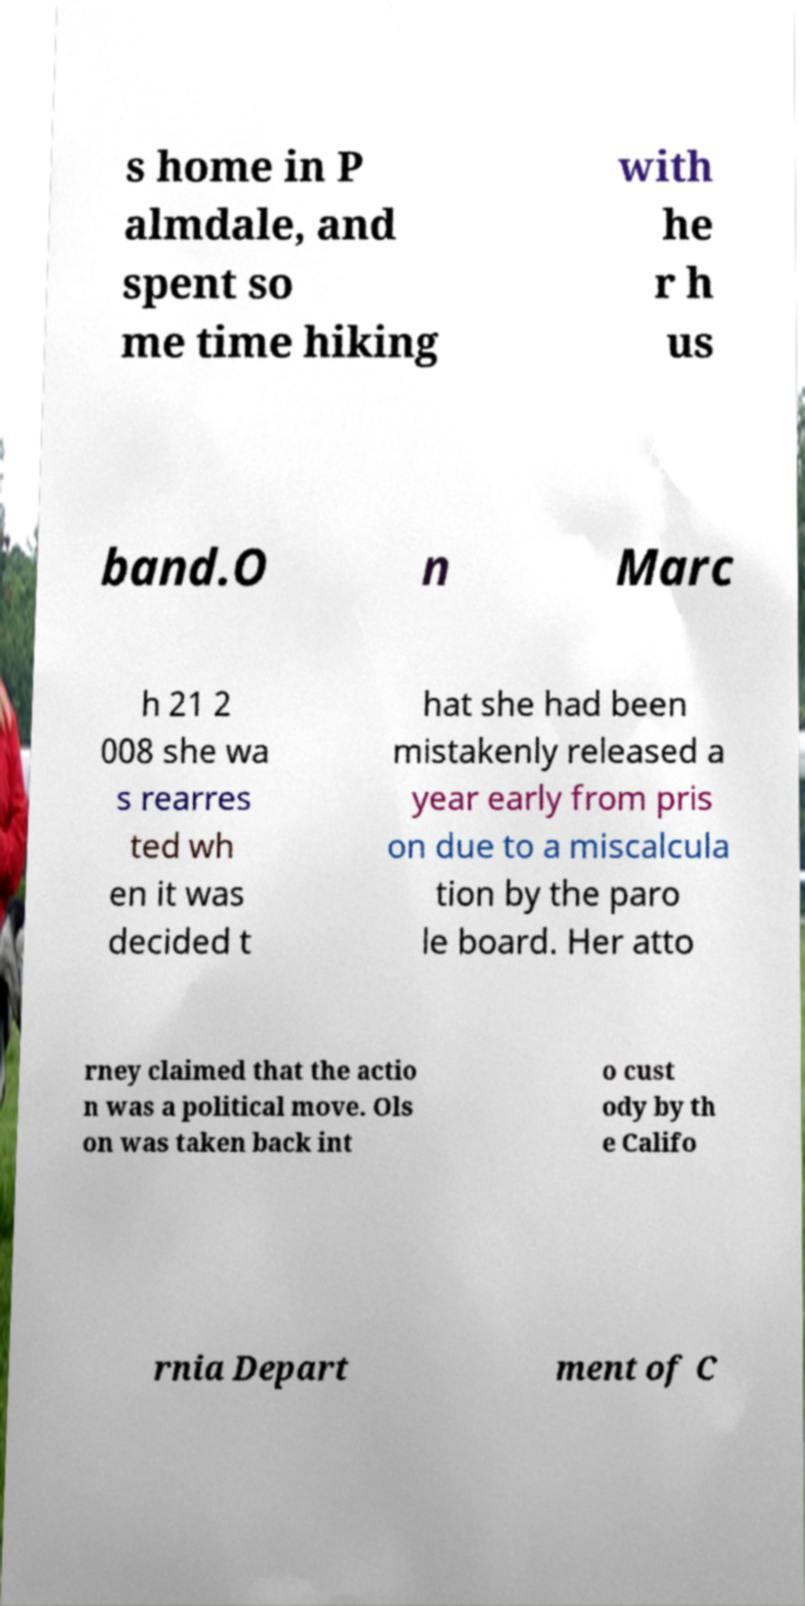Could you assist in decoding the text presented in this image and type it out clearly? s home in P almdale, and spent so me time hiking with he r h us band.O n Marc h 21 2 008 she wa s rearres ted wh en it was decided t hat she had been mistakenly released a year early from pris on due to a miscalcula tion by the paro le board. Her atto rney claimed that the actio n was a political move. Ols on was taken back int o cust ody by th e Califo rnia Depart ment of C 